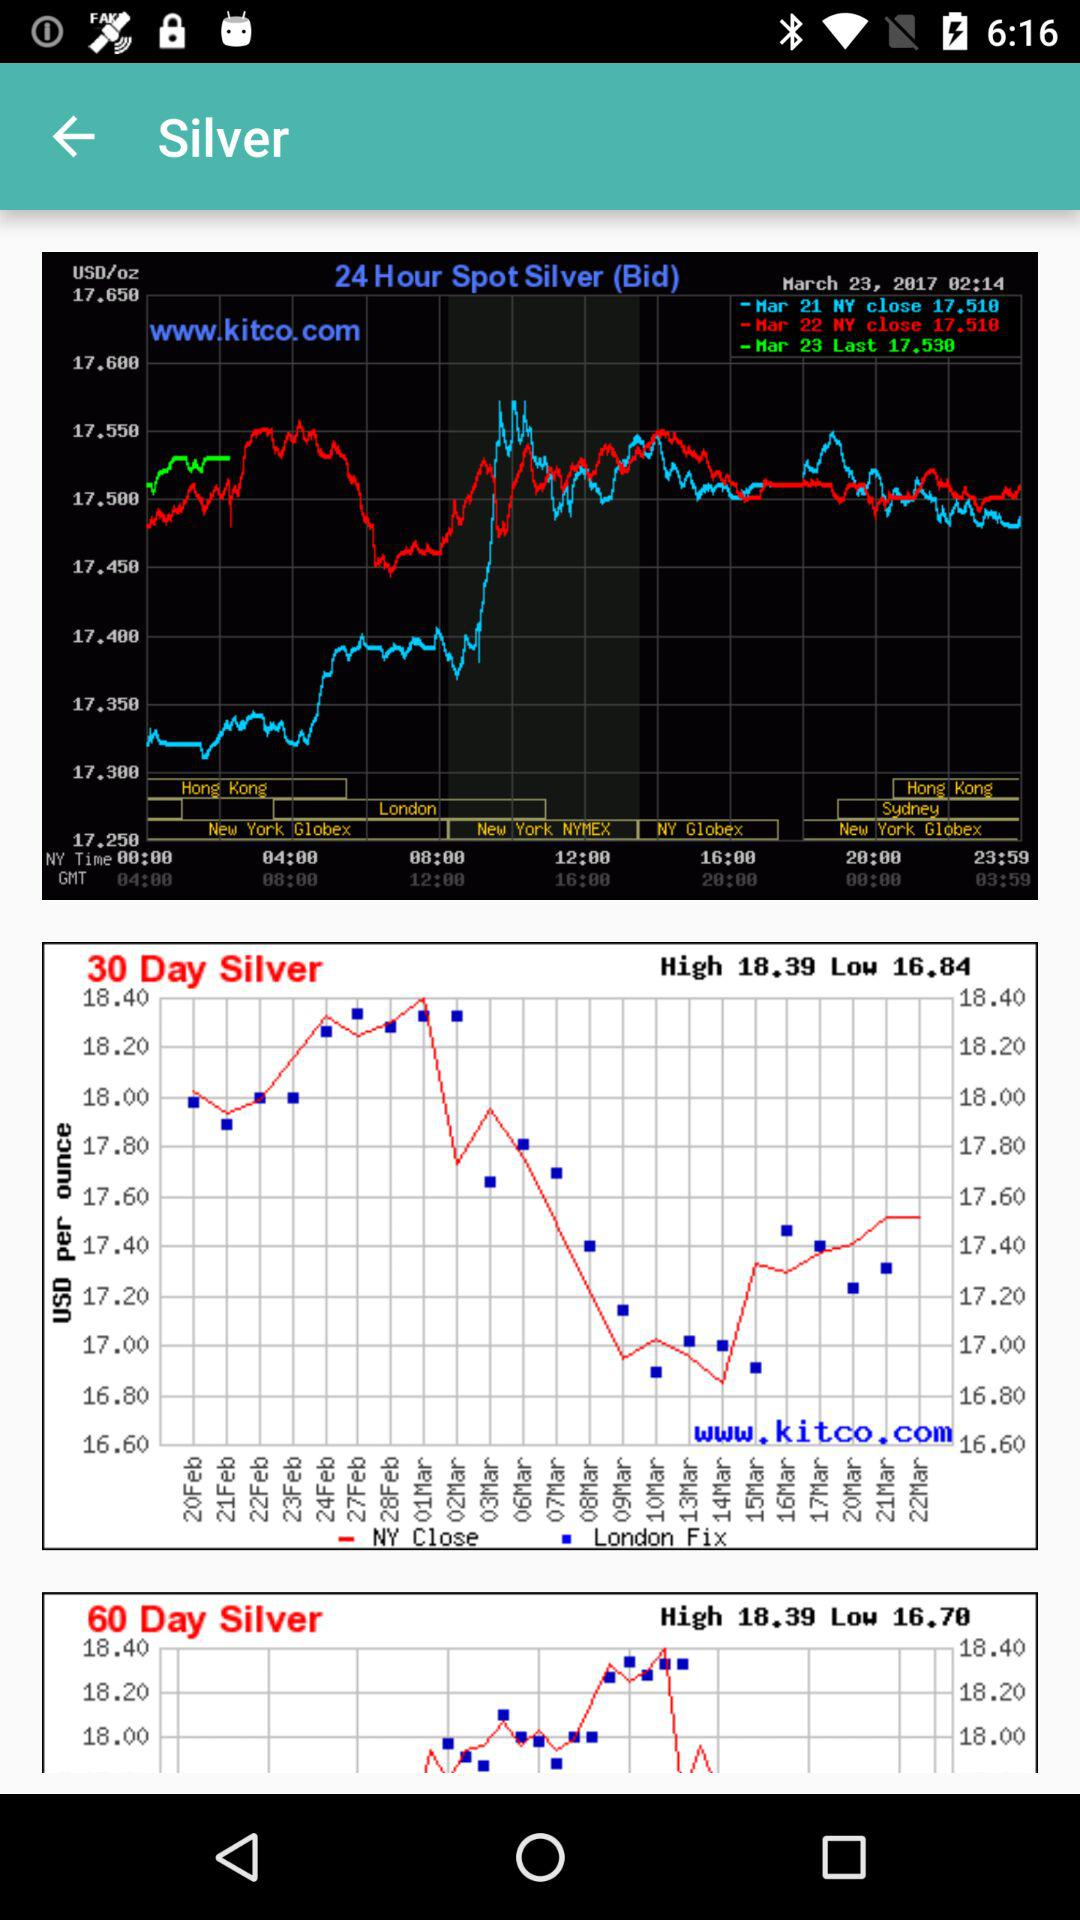What is the high value of "30 day silver"? The high value is 18.39. 